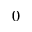<formula> <loc_0><loc_0><loc_500><loc_500>0</formula> 